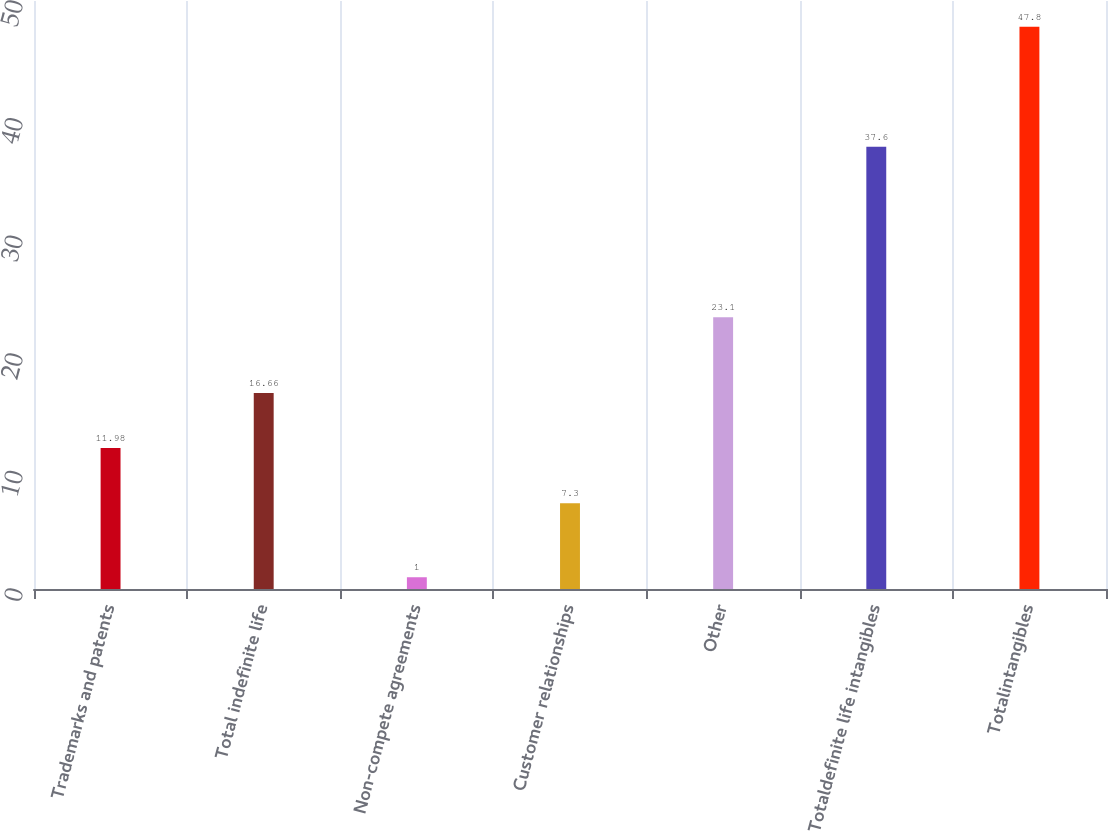<chart> <loc_0><loc_0><loc_500><loc_500><bar_chart><fcel>Trademarks and patents<fcel>Total indefinite life<fcel>Non-compete agreements<fcel>Customer relationships<fcel>Other<fcel>Totaldefinite life intangibles<fcel>Totalintangibles<nl><fcel>11.98<fcel>16.66<fcel>1<fcel>7.3<fcel>23.1<fcel>37.6<fcel>47.8<nl></chart> 